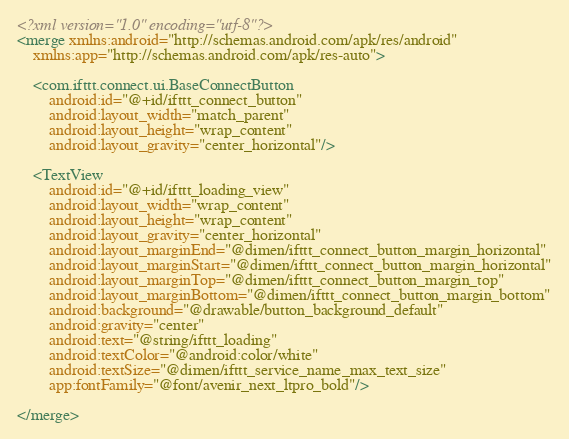Convert code to text. <code><loc_0><loc_0><loc_500><loc_500><_XML_><?xml version="1.0" encoding="utf-8"?>
<merge xmlns:android="http://schemas.android.com/apk/res/android"
    xmlns:app="http://schemas.android.com/apk/res-auto">

    <com.ifttt.connect.ui.BaseConnectButton
        android:id="@+id/ifttt_connect_button"
        android:layout_width="match_parent"
        android:layout_height="wrap_content"
        android:layout_gravity="center_horizontal"/>

    <TextView
        android:id="@+id/ifttt_loading_view"
        android:layout_width="wrap_content"
        android:layout_height="wrap_content"
        android:layout_gravity="center_horizontal"
        android:layout_marginEnd="@dimen/ifttt_connect_button_margin_horizontal"
        android:layout_marginStart="@dimen/ifttt_connect_button_margin_horizontal"
        android:layout_marginTop="@dimen/ifttt_connect_button_margin_top"
        android:layout_marginBottom="@dimen/ifttt_connect_button_margin_bottom"
        android:background="@drawable/button_background_default"
        android:gravity="center"
        android:text="@string/ifttt_loading"
        android:textColor="@android:color/white"
        android:textSize="@dimen/ifttt_service_name_max_text_size"
        app:fontFamily="@font/avenir_next_ltpro_bold"/>

</merge>
</code> 